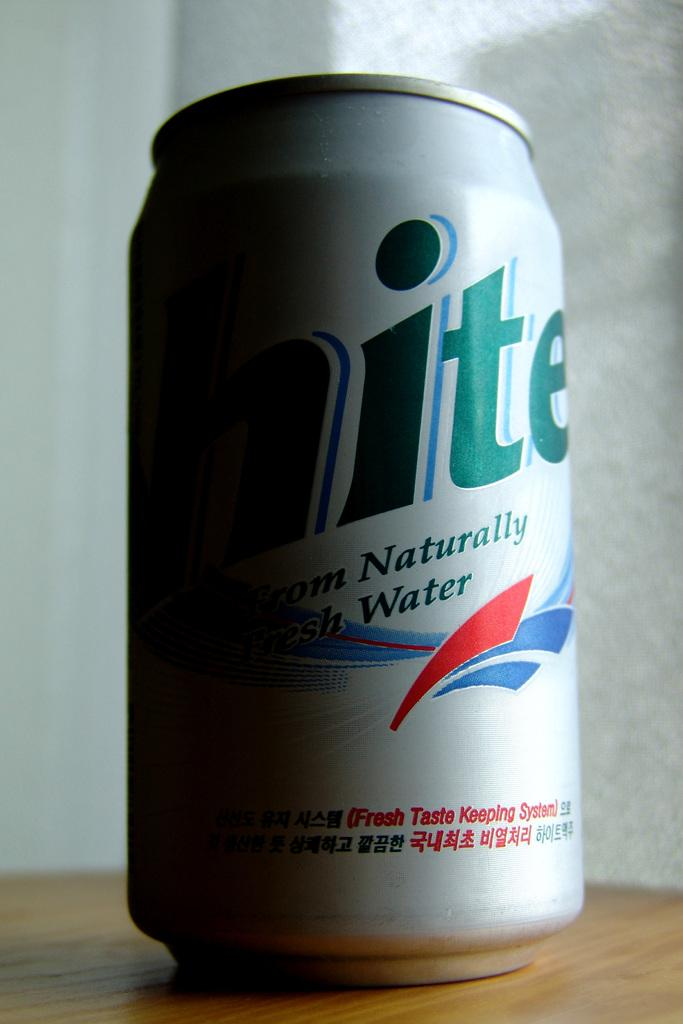What is located at the bottom of the image? There is a table at the bottom of the image. What object is on the table? There is a tin on the table. What can be seen behind the tin? There is a wall behind the tin. What type of cheese is being stored in the nest behind the tin? There is no nest or cheese present in the image. 